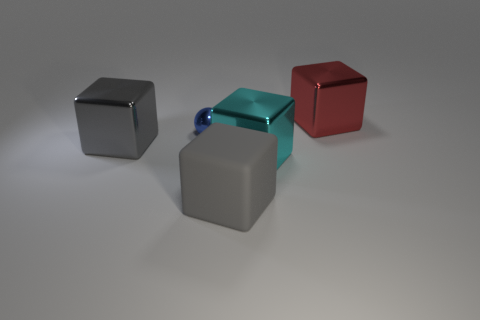Subtract all metal cubes. How many cubes are left? 1 Add 4 blue things. How many objects exist? 9 Subtract all red blocks. How many blocks are left? 3 Subtract all balls. How many objects are left? 4 Subtract 1 balls. How many balls are left? 0 Subtract all gray balls. Subtract all green blocks. How many balls are left? 1 Add 5 small blue metal objects. How many small blue metal objects exist? 6 Subtract 0 cyan spheres. How many objects are left? 5 Subtract all brown blocks. How many cyan balls are left? 0 Subtract all blue objects. Subtract all big blue matte spheres. How many objects are left? 4 